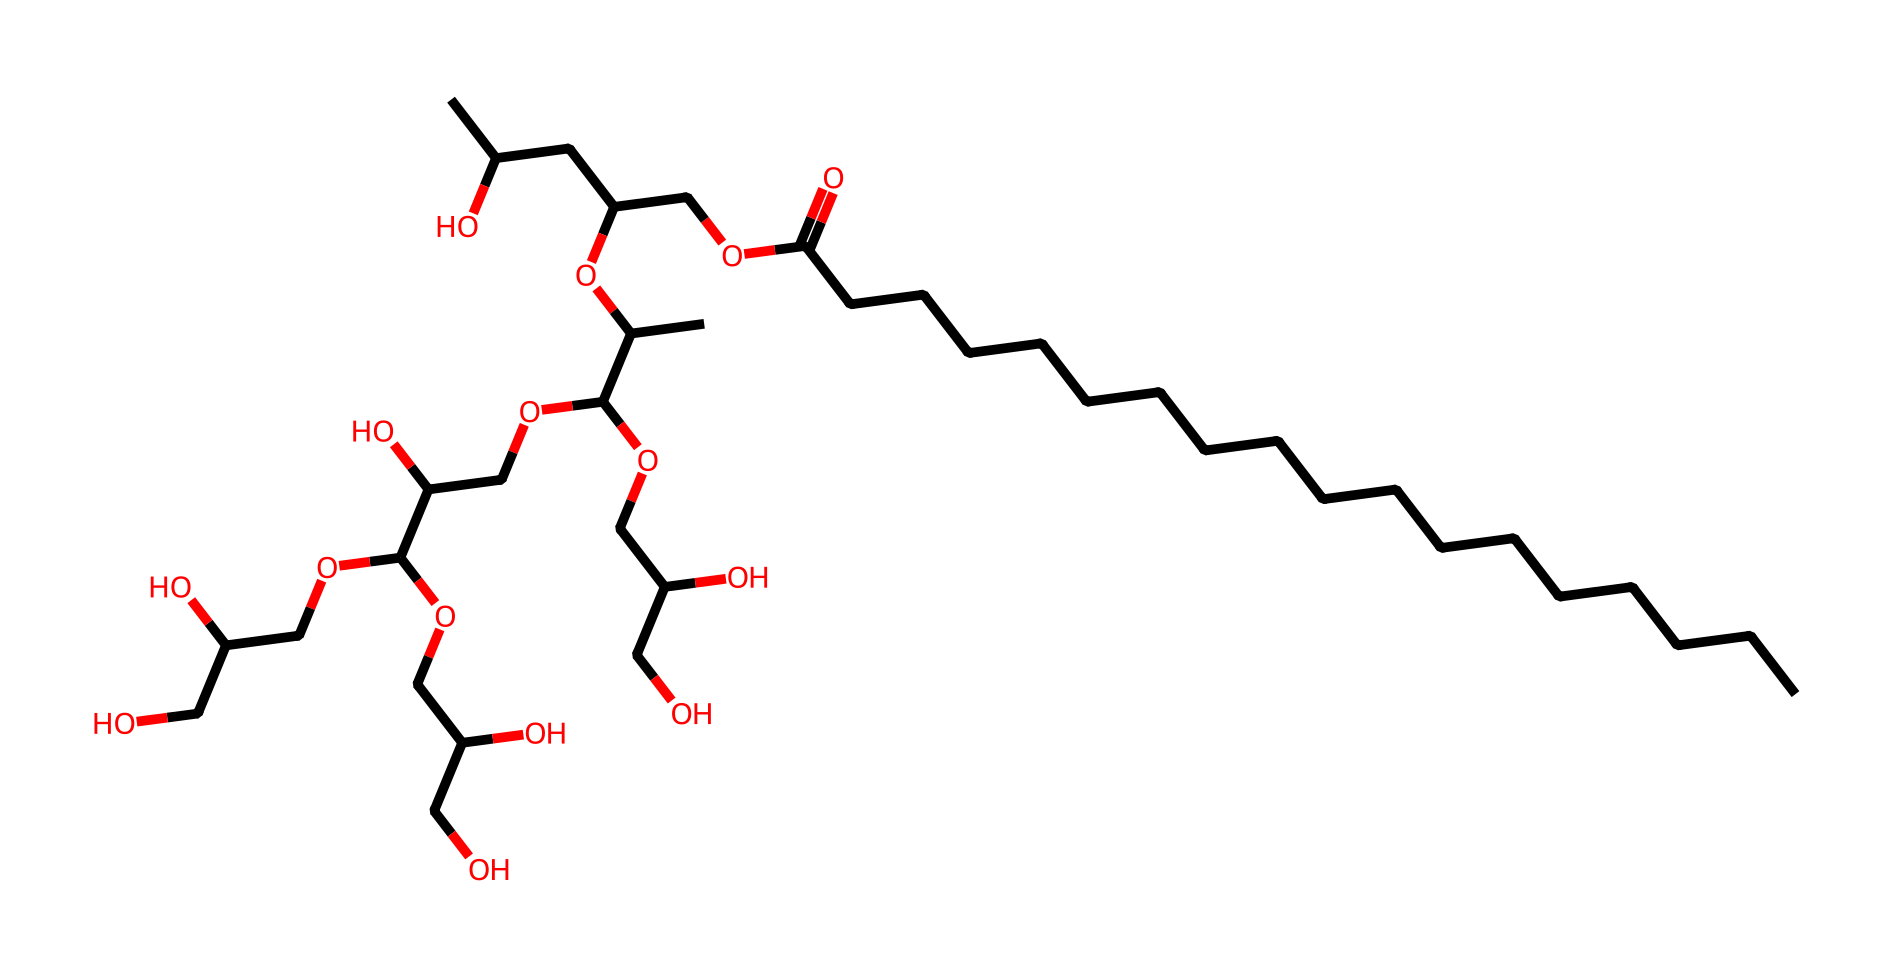What is the total number of carbon atoms in polysorbate 20? By analyzing the SMILES representation, we can count the 'C' characters which indicate carbon atoms. The structure consists of multiple carbon chains, and by careful counting, it totals to 20 carbon atoms.
Answer: twenty How many hydroxyl (–OH) groups are present in polysorbate 20? The presence of 'O' followed by 'C' in the SMILES indicates hydroxyl groups. Each 'C' bonded to an 'O' signifies a hydroxyl group. By examining the structure, we can determine there are six hydroxyl groups in total.
Answer: six What type of surfactant is polysorbate 20? Polysorbate 20 is classified as a non-ionic surfactant. By understanding that it contains polyethylene glycol and sorbitol derivatives, we can categorize it as non-ionic due to the absence of charged groups in its structure.
Answer: non-ionic What functional group is primarily responsible for the emulsifying properties of polysorbate 20? The chemical features multiple hydroxyl groups and an ester linkage. These hydroxyl groups facilitate the emulsifying properties, allowing it to interact with both water and oils effectively, thus creating stable emulsions.
Answer: hydroxyl group What is the main purpose of including polysorbate 20 in sunscreen formulations? Polysorbate 20 helps in solubilizing and stabilizing the formula, enhancing the consistency and application of the sunscreen. Its emulsifying properties ensure that oil and water components mix uniformly, which is essential for effective sunscreen usage.
Answer: emulsifier How does polysorbate 20 improve the spreadability of sunscreen on the skin? The presence of long hydrophobic carbon chains allows for better film formation and spreadability on the skin. In addition, the hydroxyl groups enable hydrophilicity, improving the interaction with the skin surface for easier application.
Answer: improves spreadability 